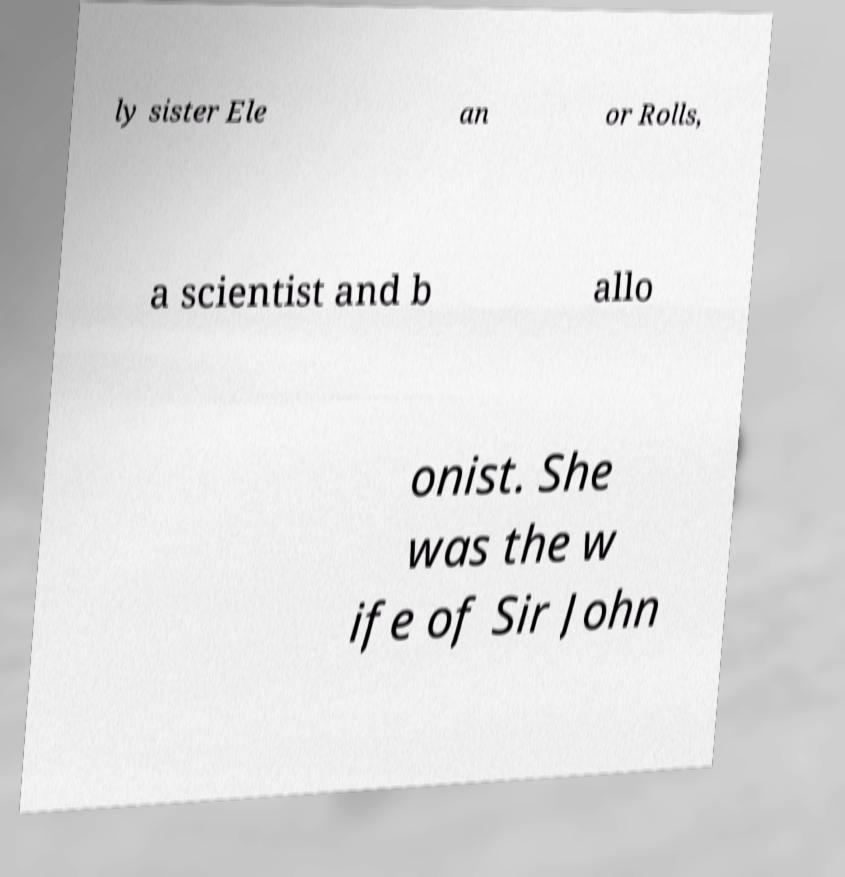Can you read and provide the text displayed in the image?This photo seems to have some interesting text. Can you extract and type it out for me? ly sister Ele an or Rolls, a scientist and b allo onist. She was the w ife of Sir John 